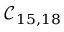<formula> <loc_0><loc_0><loc_500><loc_500>\mathcal { C } _ { 1 5 , 1 8 }</formula> 